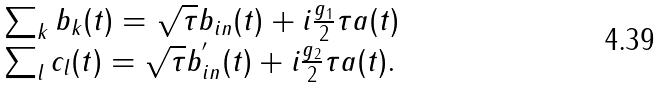Convert formula to latex. <formula><loc_0><loc_0><loc_500><loc_500>\begin{array} { l } \sum _ { k } b _ { k } ( t ) = \sqrt { \tau } b _ { i n } ( t ) + i \frac { g _ { 1 } } { 2 } \tau a ( t ) \\ \sum _ { l } c _ { l } ( t ) = \sqrt { \tau } b ^ { ^ { \prime } } _ { i n } ( t ) + i \frac { g _ { 2 } } { 2 } \tau a ( t ) . \end{array}</formula> 